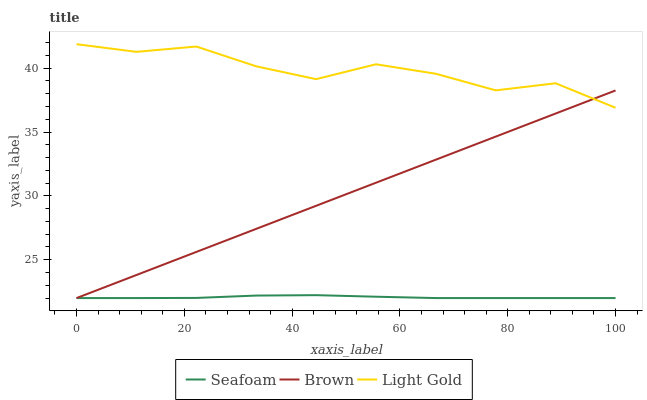Does Seafoam have the minimum area under the curve?
Answer yes or no. Yes. Does Light Gold have the maximum area under the curve?
Answer yes or no. Yes. Does Light Gold have the minimum area under the curve?
Answer yes or no. No. Does Seafoam have the maximum area under the curve?
Answer yes or no. No. Is Brown the smoothest?
Answer yes or no. Yes. Is Light Gold the roughest?
Answer yes or no. Yes. Is Seafoam the smoothest?
Answer yes or no. No. Is Seafoam the roughest?
Answer yes or no. No. Does Light Gold have the lowest value?
Answer yes or no. No. Does Seafoam have the highest value?
Answer yes or no. No. Is Seafoam less than Light Gold?
Answer yes or no. Yes. Is Light Gold greater than Seafoam?
Answer yes or no. Yes. Does Seafoam intersect Light Gold?
Answer yes or no. No. 